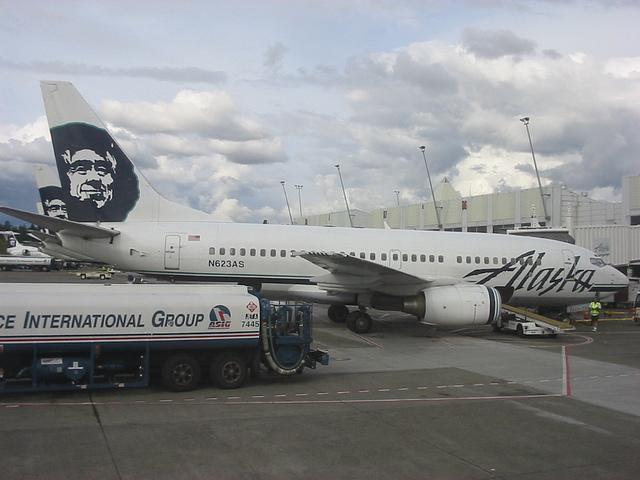How many people are in this image?
Give a very brief answer. 1. 